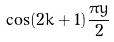Convert formula to latex. <formula><loc_0><loc_0><loc_500><loc_500>\cos ( 2 k + 1 ) \frac { \pi y } { 2 }</formula> 